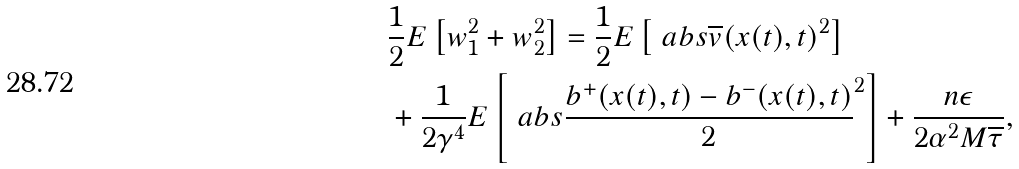<formula> <loc_0><loc_0><loc_500><loc_500>& \frac { 1 } { 2 } E \left [ w ^ { 2 } _ { 1 } + w ^ { 2 } _ { 2 } \right ] = \frac { 1 } { 2 } E \left [ \ a b s { \overline { v } ( x ( t ) , t ) } ^ { 2 } \right ] \\ & + \frac { 1 } { 2 \gamma ^ { 4 } } E \left [ \ a b s { \frac { b ^ { + } ( x ( t ) , t ) - b ^ { - } ( x ( t ) , t ) } { 2 } } ^ { 2 } \right ] + \frac { n \epsilon } { 2 \alpha ^ { 2 } M \overline { \tau } } ,</formula> 